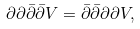<formula> <loc_0><loc_0><loc_500><loc_500>\partial \partial \bar { \partial } \bar { \partial } V = \bar { \partial } \bar { \partial } \partial \partial V ,</formula> 